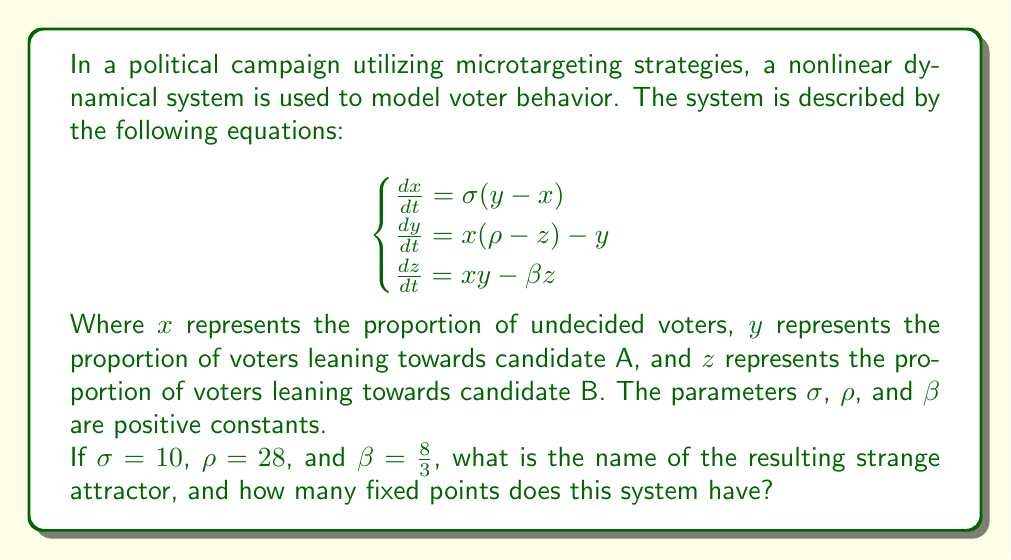Teach me how to tackle this problem. To answer this question, we need to analyze the given system of equations and recognize its characteristics:

1. The system of equations presented is the Lorenz system, a classic example of a chaotic system that exhibits strange attractors.

2. With the given parameters $\sigma = 10$, $\rho = 28$, and $\beta = \frac{8}{3}$, this system specifically produces the Lorenz attractor, also known as the "butterfly attractor" due to its shape resembling butterfly wings.

3. To find the fixed points of the system, we set all derivatives to zero:

   $$\begin{cases}
   0 = \sigma(y - x) \\
   0 = x(\rho - z) - y \\
   0 = xy - \beta z
   \end{cases}$$

4. From the first equation: $y = x$

5. Substituting this into the second and third equations:
   
   $$\begin{cases}
   0 = x(\rho - z) - x \\
   0 = x^2 - \beta z
   \end{cases}$$

6. From the first equation: $x(\rho - z - 1) = 0$, so either $x = 0$ or $\rho - z - 1 = 0$

7. Case 1: If $x = 0$, then $y = 0$ and $z = 0$. This gives us the origin (0, 0, 0) as a fixed point.

8. Case 2: If $\rho - z - 1 = 0$, then $z = \rho - 1$. Substituting into $x^2 = \beta z$:
   
   $$x^2 = \beta(\rho - 1)$$
   $$x = \pm \sqrt{\beta(\rho - 1)}$$

9. This gives us two more fixed points:
   
   $$(\sqrt{\beta(\rho - 1)}, \sqrt{\beta(\rho - 1)}, \rho - 1)$$
   $$(-\sqrt{\beta(\rho - 1)}, -\sqrt{\beta(\rho - 1)}, \rho - 1)$$

Therefore, the system has three fixed points in total.
Answer: Lorenz attractor; 3 fixed points 